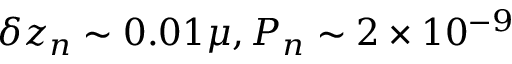<formula> <loc_0><loc_0><loc_500><loc_500>\delta z _ { n } \sim 0 . 0 1 \mu , P _ { n } \sim 2 \times 1 0 ^ { - 9 }</formula> 